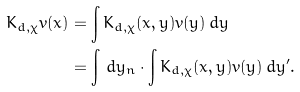<formula> <loc_0><loc_0><loc_500><loc_500>K _ { d , \chi } v ( x ) & = \int K _ { d , \chi } ( x , y ) v ( y ) \, d y \\ & = \int \, d y _ { n } \cdot \int K _ { d , \chi } ( x , y ) v ( y ) \, d y ^ { \prime } .</formula> 